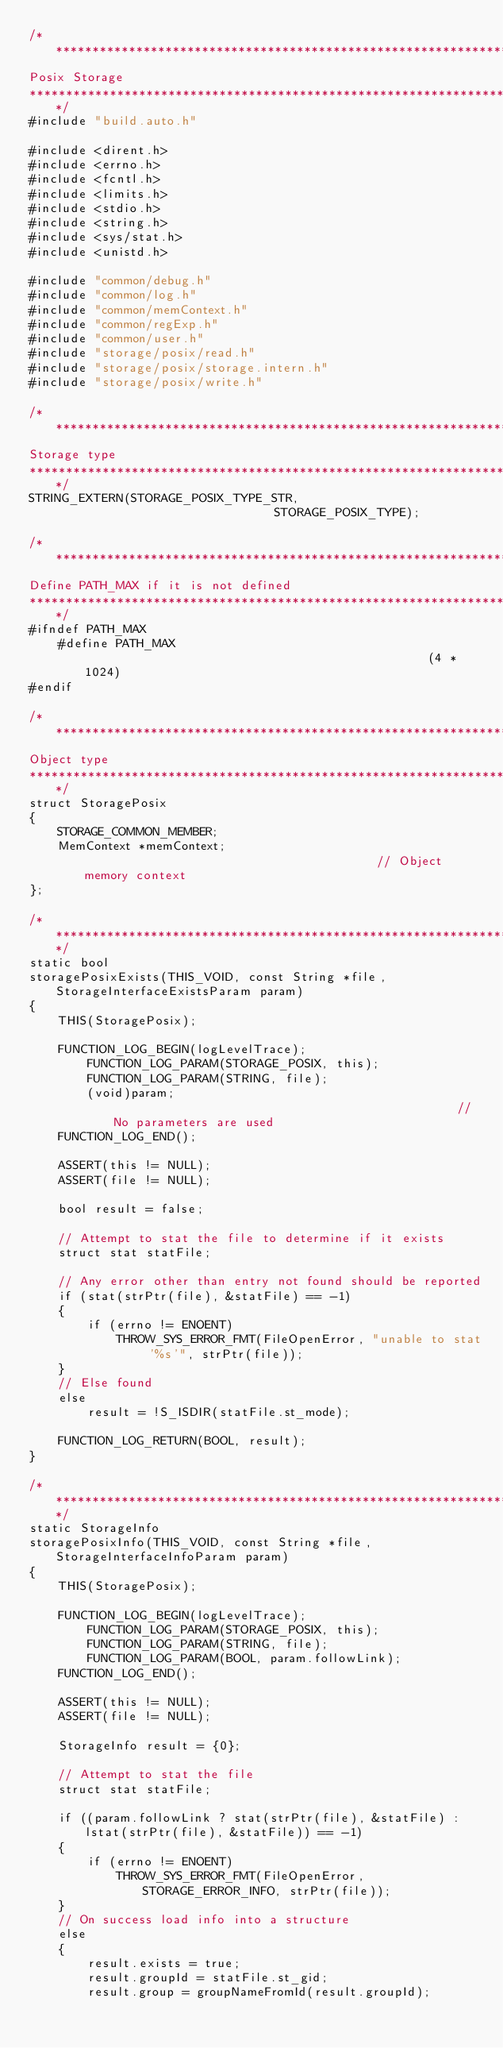<code> <loc_0><loc_0><loc_500><loc_500><_C_>/***********************************************************************************************************************************
Posix Storage
***********************************************************************************************************************************/
#include "build.auto.h"

#include <dirent.h>
#include <errno.h>
#include <fcntl.h>
#include <limits.h>
#include <stdio.h>
#include <string.h>
#include <sys/stat.h>
#include <unistd.h>

#include "common/debug.h"
#include "common/log.h"
#include "common/memContext.h"
#include "common/regExp.h"
#include "common/user.h"
#include "storage/posix/read.h"
#include "storage/posix/storage.intern.h"
#include "storage/posix/write.h"

/***********************************************************************************************************************************
Storage type
***********************************************************************************************************************************/
STRING_EXTERN(STORAGE_POSIX_TYPE_STR,                               STORAGE_POSIX_TYPE);

/***********************************************************************************************************************************
Define PATH_MAX if it is not defined
***********************************************************************************************************************************/
#ifndef PATH_MAX
    #define PATH_MAX                                                (4 * 1024)
#endif

/***********************************************************************************************************************************
Object type
***********************************************************************************************************************************/
struct StoragePosix
{
    STORAGE_COMMON_MEMBER;
    MemContext *memContext;                                         // Object memory context
};

/**********************************************************************************************************************************/
static bool
storagePosixExists(THIS_VOID, const String *file, StorageInterfaceExistsParam param)
{
    THIS(StoragePosix);

    FUNCTION_LOG_BEGIN(logLevelTrace);
        FUNCTION_LOG_PARAM(STORAGE_POSIX, this);
        FUNCTION_LOG_PARAM(STRING, file);
        (void)param;                                                // No parameters are used
    FUNCTION_LOG_END();

    ASSERT(this != NULL);
    ASSERT(file != NULL);

    bool result = false;

    // Attempt to stat the file to determine if it exists
    struct stat statFile;

    // Any error other than entry not found should be reported
    if (stat(strPtr(file), &statFile) == -1)
    {
        if (errno != ENOENT)
            THROW_SYS_ERROR_FMT(FileOpenError, "unable to stat '%s'", strPtr(file));
    }
    // Else found
    else
        result = !S_ISDIR(statFile.st_mode);

    FUNCTION_LOG_RETURN(BOOL, result);
}

/**********************************************************************************************************************************/
static StorageInfo
storagePosixInfo(THIS_VOID, const String *file, StorageInterfaceInfoParam param)
{
    THIS(StoragePosix);

    FUNCTION_LOG_BEGIN(logLevelTrace);
        FUNCTION_LOG_PARAM(STORAGE_POSIX, this);
        FUNCTION_LOG_PARAM(STRING, file);
        FUNCTION_LOG_PARAM(BOOL, param.followLink);
    FUNCTION_LOG_END();

    ASSERT(this != NULL);
    ASSERT(file != NULL);

    StorageInfo result = {0};

    // Attempt to stat the file
    struct stat statFile;

    if ((param.followLink ? stat(strPtr(file), &statFile) : lstat(strPtr(file), &statFile)) == -1)
    {
        if (errno != ENOENT)
            THROW_SYS_ERROR_FMT(FileOpenError, STORAGE_ERROR_INFO, strPtr(file));
    }
    // On success load info into a structure
    else
    {
        result.exists = true;
        result.groupId = statFile.st_gid;
        result.group = groupNameFromId(result.groupId);</code> 